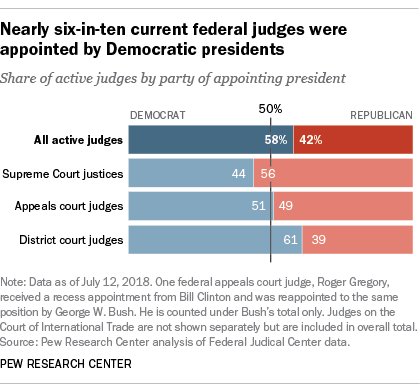Specify some key components in this picture. The color red represents the Republican Party. The value of Republicans and Democrats in District court judges is higher than that of Appeals court judges. 